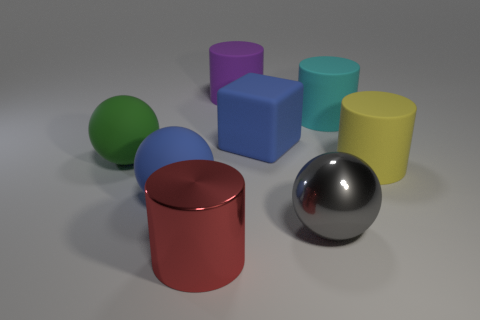Subtract all large red cylinders. How many cylinders are left? 3 Subtract all purple cylinders. How many cylinders are left? 3 Add 1 large purple cylinders. How many objects exist? 9 Subtract 1 cylinders. How many cylinders are left? 3 Subtract all cubes. How many objects are left? 7 Subtract all cyan cubes. How many yellow cylinders are left? 1 Subtract 0 brown spheres. How many objects are left? 8 Subtract all cyan balls. Subtract all red cubes. How many balls are left? 3 Subtract all large cyan cylinders. Subtract all big yellow cylinders. How many objects are left? 6 Add 7 rubber cubes. How many rubber cubes are left? 8 